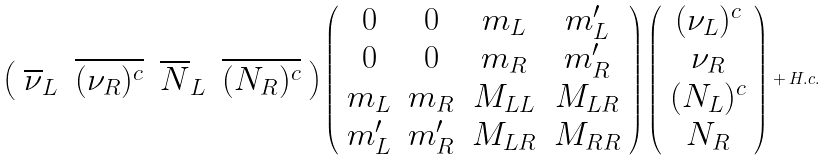Convert formula to latex. <formula><loc_0><loc_0><loc_500><loc_500>\left ( \begin{array} { c c c c } { { \overline { \nu } _ { L } } } & { { \overline { { { ( \nu _ { R } ) ^ { c } } } } } } & { { \overline { N } _ { L } } } & { { \overline { { { ( N _ { R } ) ^ { c } } } } } } \end{array} \right ) \left ( \begin{array} { c c c c } { 0 } & { 0 } & { { m _ { L } } } & { { m _ { L } ^ { \prime } } } \\ { 0 } & { 0 } & { { m _ { R } } } & { { m _ { R } ^ { \prime } } } \\ { { m _ { L } } } & { { m _ { R } } } & { { M _ { L L } } } & { { M _ { L R } } } \\ { { m _ { L } ^ { \prime } } } & { { m _ { R } ^ { \prime } } } & { { M _ { L R } } } & { { M _ { R R } } } \end{array} \right ) \left ( \begin{array} { c } { { ( \nu _ { L } ) ^ { c } } } \\ { { \nu _ { R } } } \\ { { ( N _ { L } ) ^ { c } } } \\ { { N _ { R } } } \end{array} \right ) + H . c .</formula> 